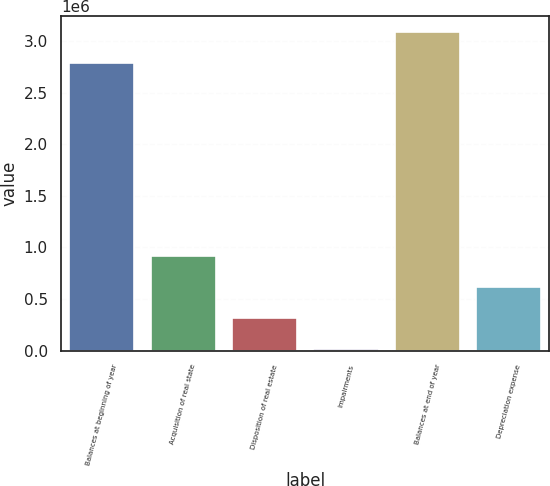Convert chart to OTSL. <chart><loc_0><loc_0><loc_500><loc_500><bar_chart><fcel>Balances at beginning of year<fcel>Acquisition of real state<fcel>Disposition of real estate<fcel>Impairments<fcel>Balances at end of year<fcel>Depreciation expense<nl><fcel>2.7838e+06<fcel>915033<fcel>314339<fcel>13992<fcel>3.08415e+06<fcel>614686<nl></chart> 